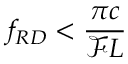<formula> <loc_0><loc_0><loc_500><loc_500>f _ { R D } < \frac { \pi c } { \mathcal { F } L }</formula> 